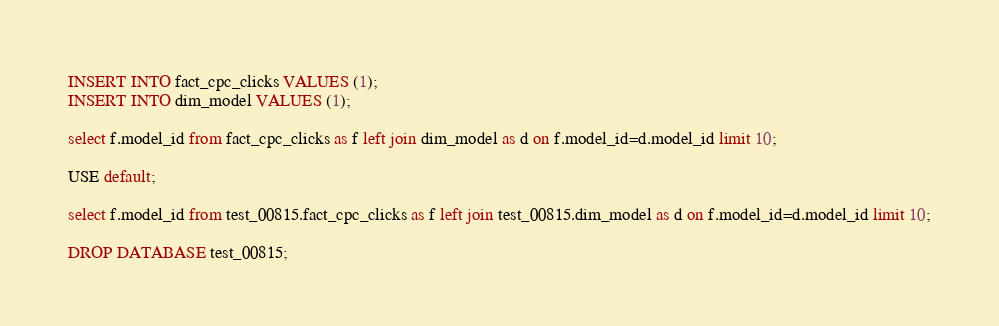<code> <loc_0><loc_0><loc_500><loc_500><_SQL_>INSERT INTO fact_cpc_clicks VALUES (1);
INSERT INTO dim_model VALUES (1);

select f.model_id from fact_cpc_clicks as f left join dim_model as d on f.model_id=d.model_id limit 10;

USE default;

select f.model_id from test_00815.fact_cpc_clicks as f left join test_00815.dim_model as d on f.model_id=d.model_id limit 10;

DROP DATABASE test_00815;
</code> 